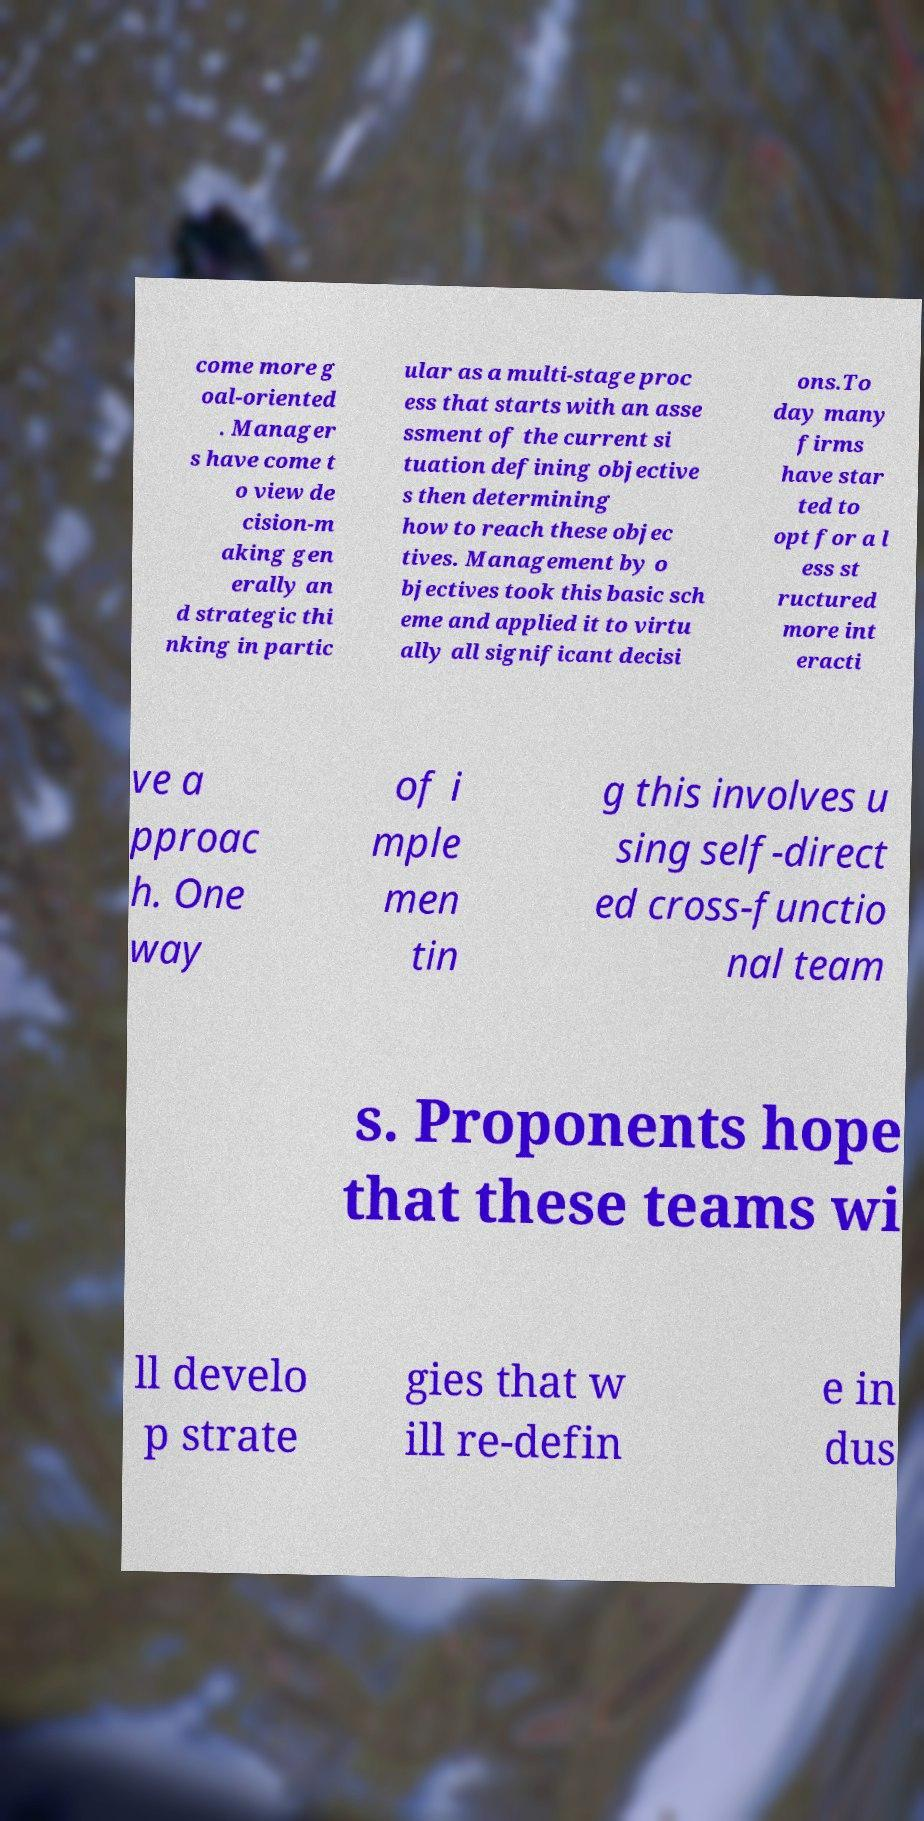Please identify and transcribe the text found in this image. come more g oal-oriented . Manager s have come t o view de cision-m aking gen erally an d strategic thi nking in partic ular as a multi-stage proc ess that starts with an asse ssment of the current si tuation defining objective s then determining how to reach these objec tives. Management by o bjectives took this basic sch eme and applied it to virtu ally all significant decisi ons.To day many firms have star ted to opt for a l ess st ructured more int eracti ve a pproac h. One way of i mple men tin g this involves u sing self-direct ed cross-functio nal team s. Proponents hope that these teams wi ll develo p strate gies that w ill re-defin e in dus 